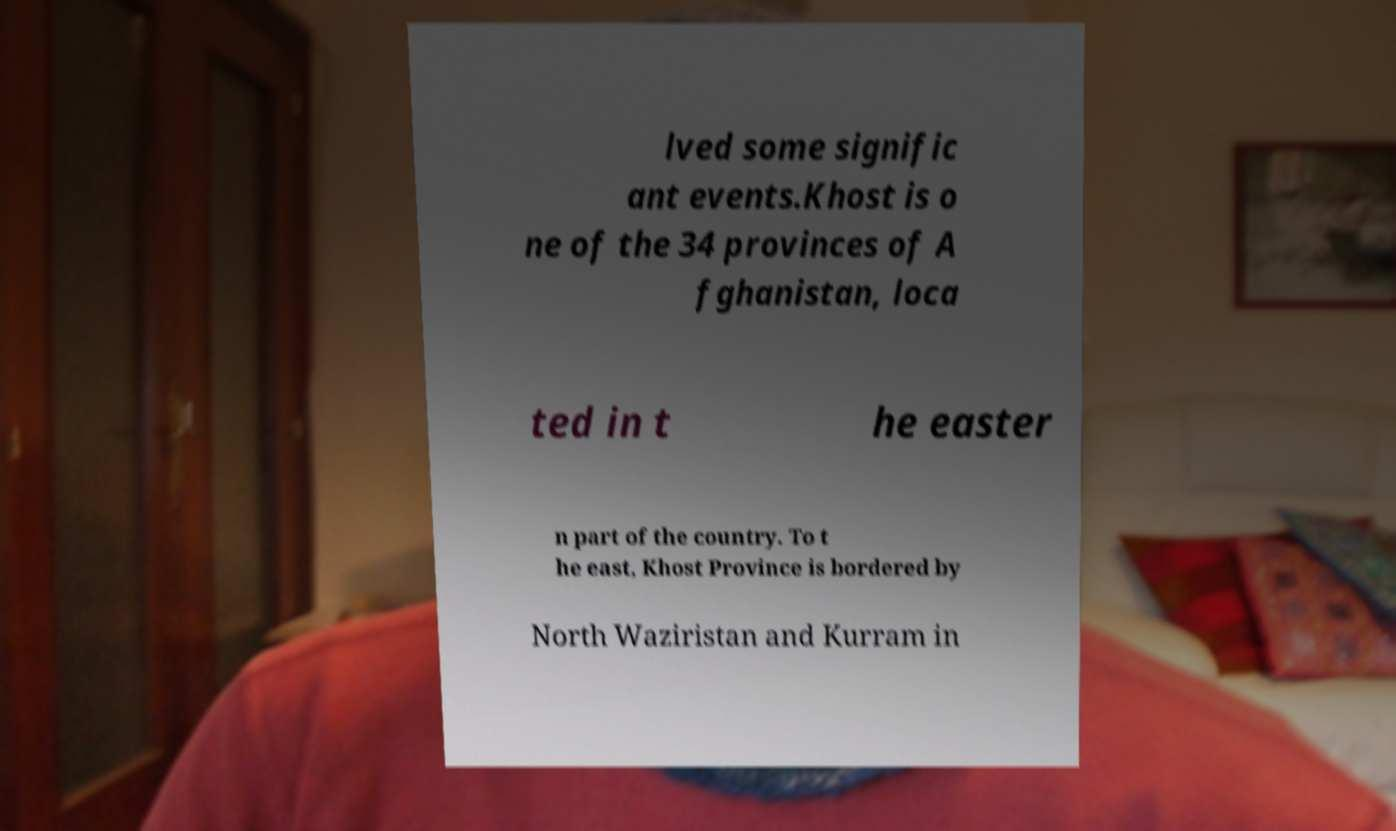Could you extract and type out the text from this image? lved some signific ant events.Khost is o ne of the 34 provinces of A fghanistan, loca ted in t he easter n part of the country. To t he east, Khost Province is bordered by North Waziristan and Kurram in 